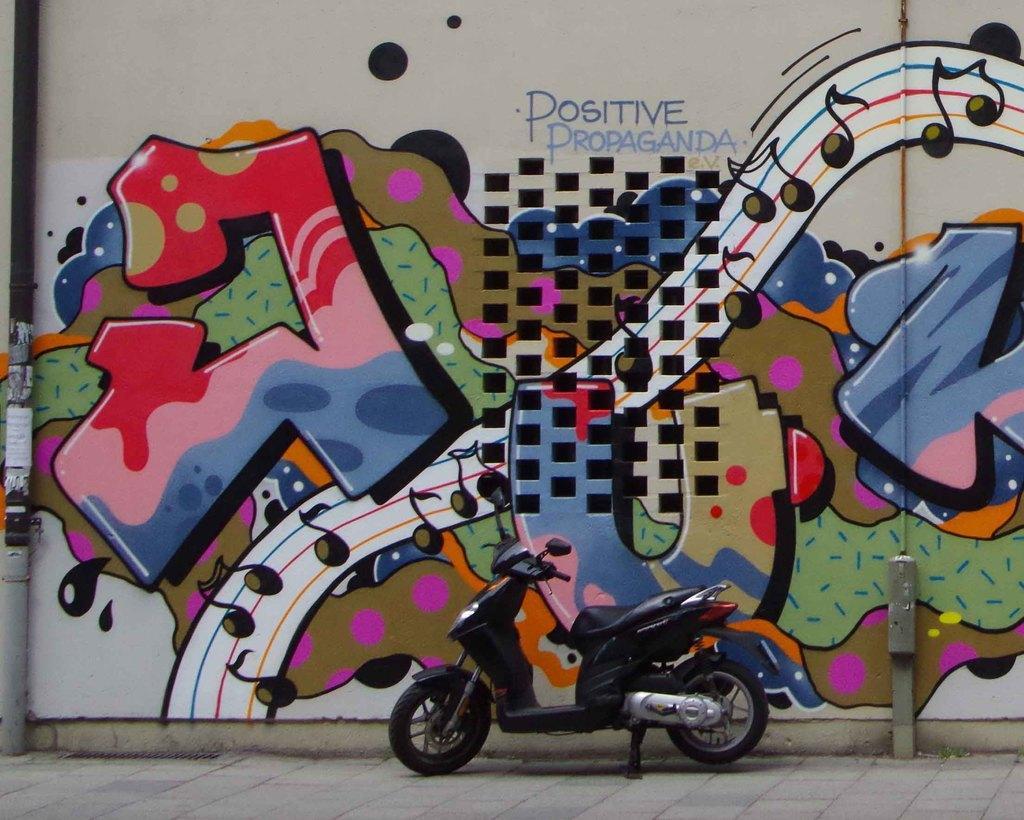How would you summarize this image in a sentence or two? In the picture there is a bike present on the road, beside there is a wall, on the wall there is a painting. 